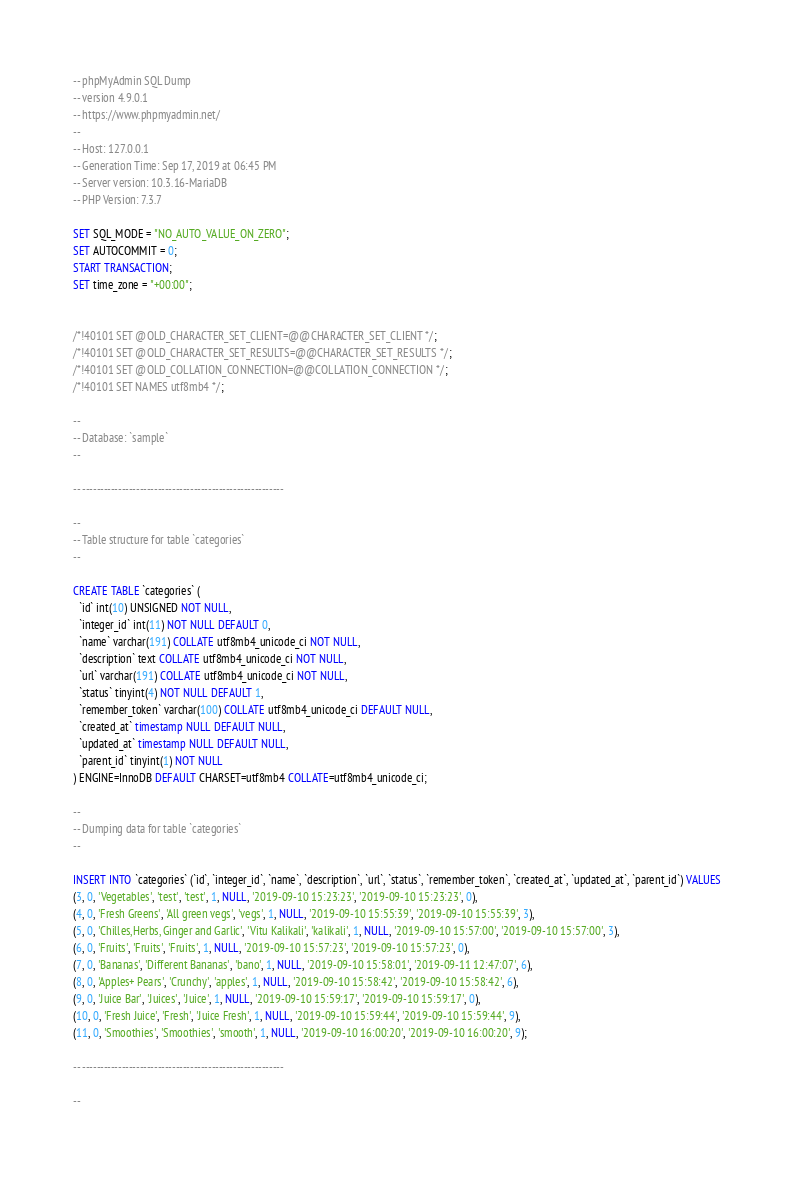<code> <loc_0><loc_0><loc_500><loc_500><_SQL_>-- phpMyAdmin SQL Dump
-- version 4.9.0.1
-- https://www.phpmyadmin.net/
--
-- Host: 127.0.0.1
-- Generation Time: Sep 17, 2019 at 06:45 PM
-- Server version: 10.3.16-MariaDB
-- PHP Version: 7.3.7

SET SQL_MODE = "NO_AUTO_VALUE_ON_ZERO";
SET AUTOCOMMIT = 0;
START TRANSACTION;
SET time_zone = "+00:00";


/*!40101 SET @OLD_CHARACTER_SET_CLIENT=@@CHARACTER_SET_CLIENT */;
/*!40101 SET @OLD_CHARACTER_SET_RESULTS=@@CHARACTER_SET_RESULTS */;
/*!40101 SET @OLD_COLLATION_CONNECTION=@@COLLATION_CONNECTION */;
/*!40101 SET NAMES utf8mb4 */;

--
-- Database: `sample`
--

-- --------------------------------------------------------

--
-- Table structure for table `categories`
--

CREATE TABLE `categories` (
  `id` int(10) UNSIGNED NOT NULL,
  `integer_id` int(11) NOT NULL DEFAULT 0,
  `name` varchar(191) COLLATE utf8mb4_unicode_ci NOT NULL,
  `description` text COLLATE utf8mb4_unicode_ci NOT NULL,
  `url` varchar(191) COLLATE utf8mb4_unicode_ci NOT NULL,
  `status` tinyint(4) NOT NULL DEFAULT 1,
  `remember_token` varchar(100) COLLATE utf8mb4_unicode_ci DEFAULT NULL,
  `created_at` timestamp NULL DEFAULT NULL,
  `updated_at` timestamp NULL DEFAULT NULL,
  `parent_id` tinyint(1) NOT NULL
) ENGINE=InnoDB DEFAULT CHARSET=utf8mb4 COLLATE=utf8mb4_unicode_ci;

--
-- Dumping data for table `categories`
--

INSERT INTO `categories` (`id`, `integer_id`, `name`, `description`, `url`, `status`, `remember_token`, `created_at`, `updated_at`, `parent_id`) VALUES
(3, 0, 'Vegetables', 'test', 'test', 1, NULL, '2019-09-10 15:23:23', '2019-09-10 15:23:23', 0),
(4, 0, 'Fresh Greens', 'All green vegs', 'vegs', 1, NULL, '2019-09-10 15:55:39', '2019-09-10 15:55:39', 3),
(5, 0, 'Chilles,Herbs, Ginger and Garlic', 'Vitu Kalikali', 'kalikali', 1, NULL, '2019-09-10 15:57:00', '2019-09-10 15:57:00', 3),
(6, 0, 'Fruits', 'Fruits', 'Fruits', 1, NULL, '2019-09-10 15:57:23', '2019-09-10 15:57:23', 0),
(7, 0, 'Bananas', 'Different Bananas', 'bano', 1, NULL, '2019-09-10 15:58:01', '2019-09-11 12:47:07', 6),
(8, 0, 'Apples+ Pears', 'Crunchy', 'apples', 1, NULL, '2019-09-10 15:58:42', '2019-09-10 15:58:42', 6),
(9, 0, 'Juice Bar', 'Juices', 'Juice', 1, NULL, '2019-09-10 15:59:17', '2019-09-10 15:59:17', 0),
(10, 0, 'Fresh Juice', 'Fresh', 'Juice Fresh', 1, NULL, '2019-09-10 15:59:44', '2019-09-10 15:59:44', 9),
(11, 0, 'Smoothies', 'Smoothies', 'smooth', 1, NULL, '2019-09-10 16:00:20', '2019-09-10 16:00:20', 9);

-- --------------------------------------------------------

--</code> 